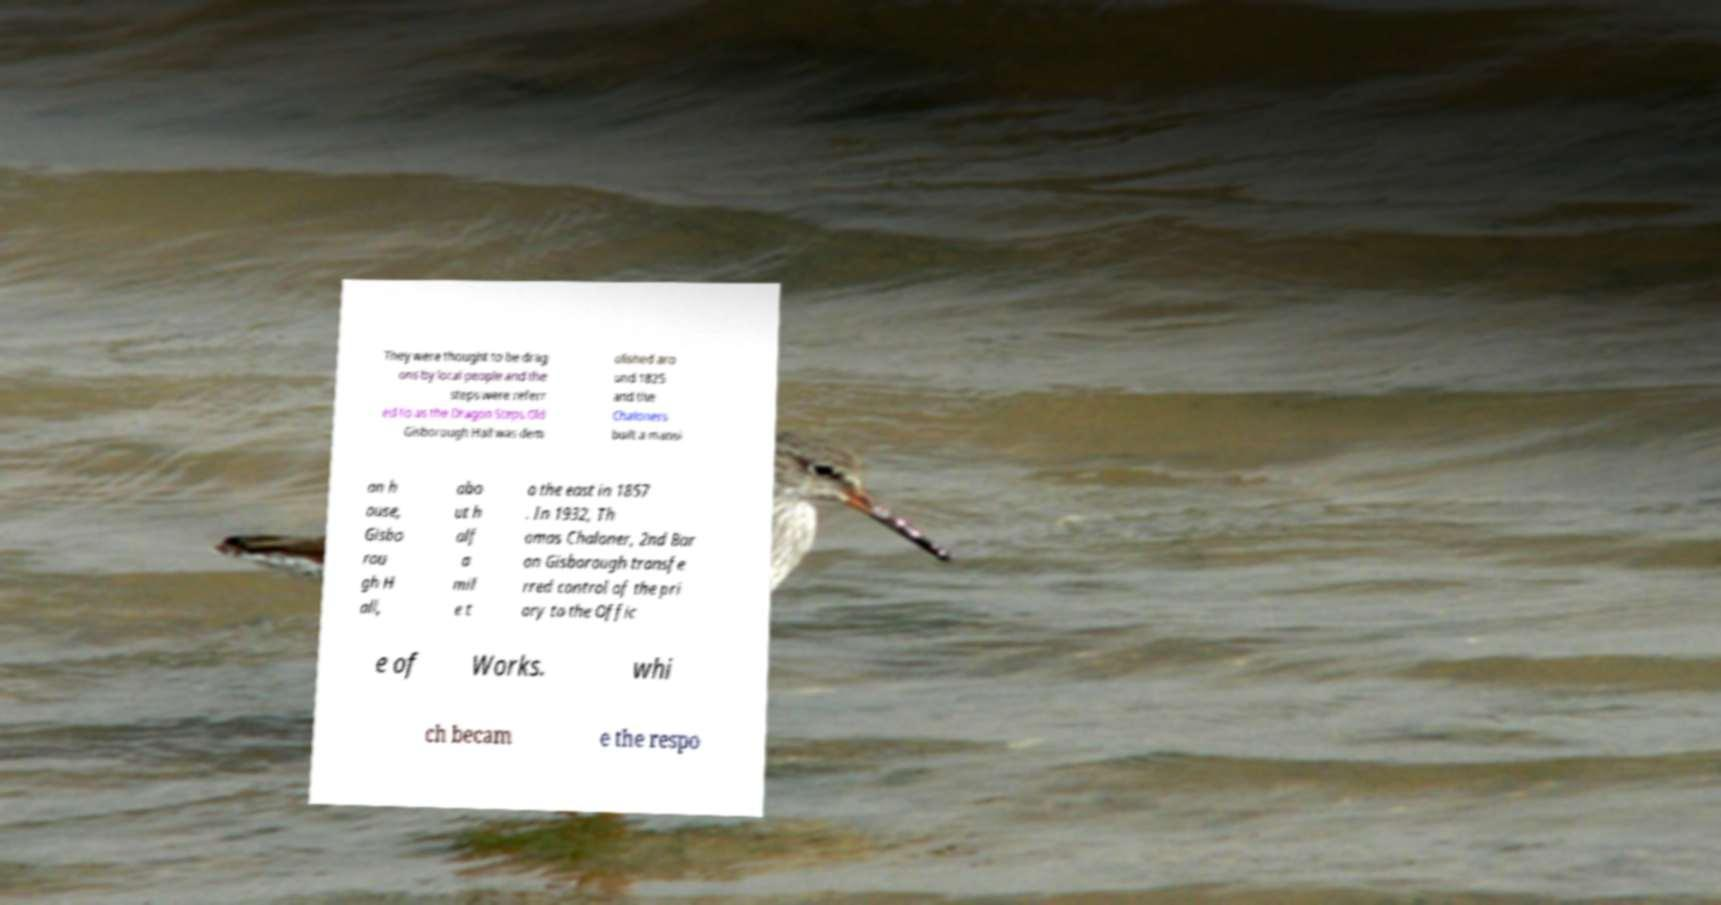For documentation purposes, I need the text within this image transcribed. Could you provide that? They were thought to be drag ons by local people and the steps were referr ed to as the Dragon Steps.Old Gisborough Hall was dem olished aro und 1825 and the Chaloners built a mansi on h ouse, Gisbo rou gh H all, abo ut h alf a mil e t o the east in 1857 . In 1932, Th omas Chaloner, 2nd Bar on Gisborough transfe rred control of the pri ory to the Offic e of Works. whi ch becam e the respo 